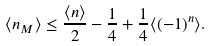<formula> <loc_0><loc_0><loc_500><loc_500>\langle n _ { M } \rangle \leq \frac { \langle n \rangle } { 2 } - \frac { 1 } { 4 } + \frac { 1 } { 4 } \langle ( - 1 ) ^ { n } \rangle .</formula> 